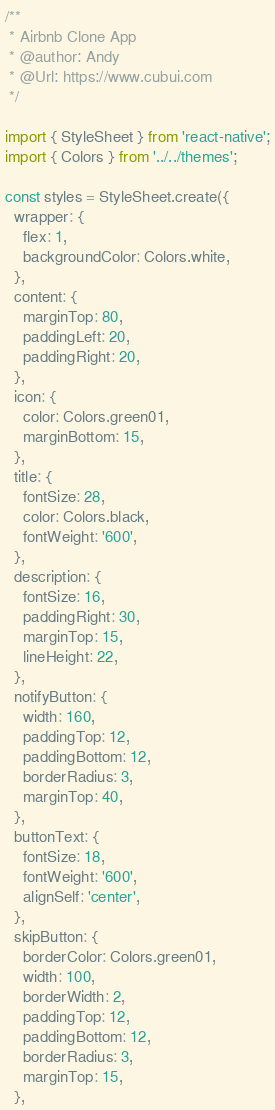Convert code to text. <code><loc_0><loc_0><loc_500><loc_500><_JavaScript_>/**
 * Airbnb Clone App
 * @author: Andy
 * @Url: https://www.cubui.com
 */

import { StyleSheet } from 'react-native';
import { Colors } from '../../themes';

const styles = StyleSheet.create({
  wrapper: {
    flex: 1,
    backgroundColor: Colors.white,
  },
  content: {
    marginTop: 80,
    paddingLeft: 20,
    paddingRight: 20,
  },
  icon: {
    color: Colors.green01,
    marginBottom: 15,
  },
  title: {
    fontSize: 28,
    color: Colors.black,
    fontWeight: '600',
  },
  description: {
    fontSize: 16,
    paddingRight: 30,
    marginTop: 15,
    lineHeight: 22,
  },
  notifyButton: {
    width: 160,
    paddingTop: 12,
    paddingBottom: 12,
    borderRadius: 3,
    marginTop: 40,
  },
  buttonText: {
    fontSize: 18,
    fontWeight: '600',
    alignSelf: 'center',
  },
  skipButton: {
    borderColor: Colors.green01,
    width: 100,
    borderWidth: 2,
    paddingTop: 12,
    paddingBottom: 12,
    borderRadius: 3,
    marginTop: 15,
  },</code> 